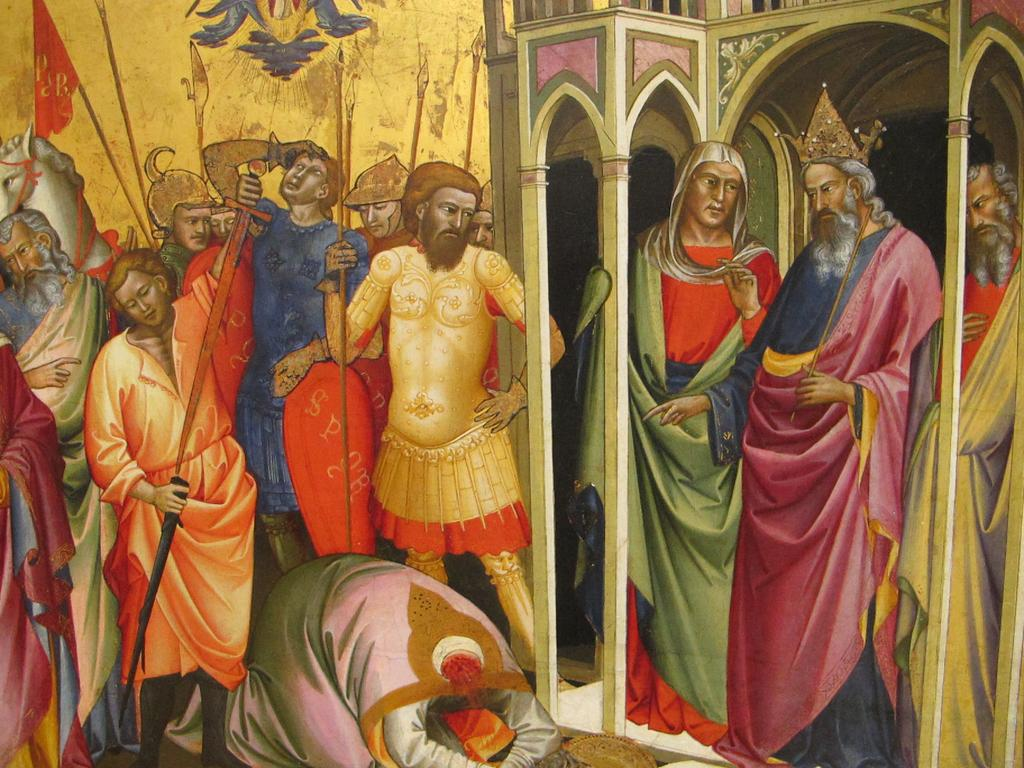What is the main subject of the image? There is a painting in the image. What is shown in the painting? The painting depicts people. What else can be seen in the image besides the painting? There is a wall in the image. How many kittens are playing with the trees in the painting? There are no kittens or trees present in the painting; it depicts people. What type of produce is featured in the painting? There is no produce featured in the painting; it depicts people. 